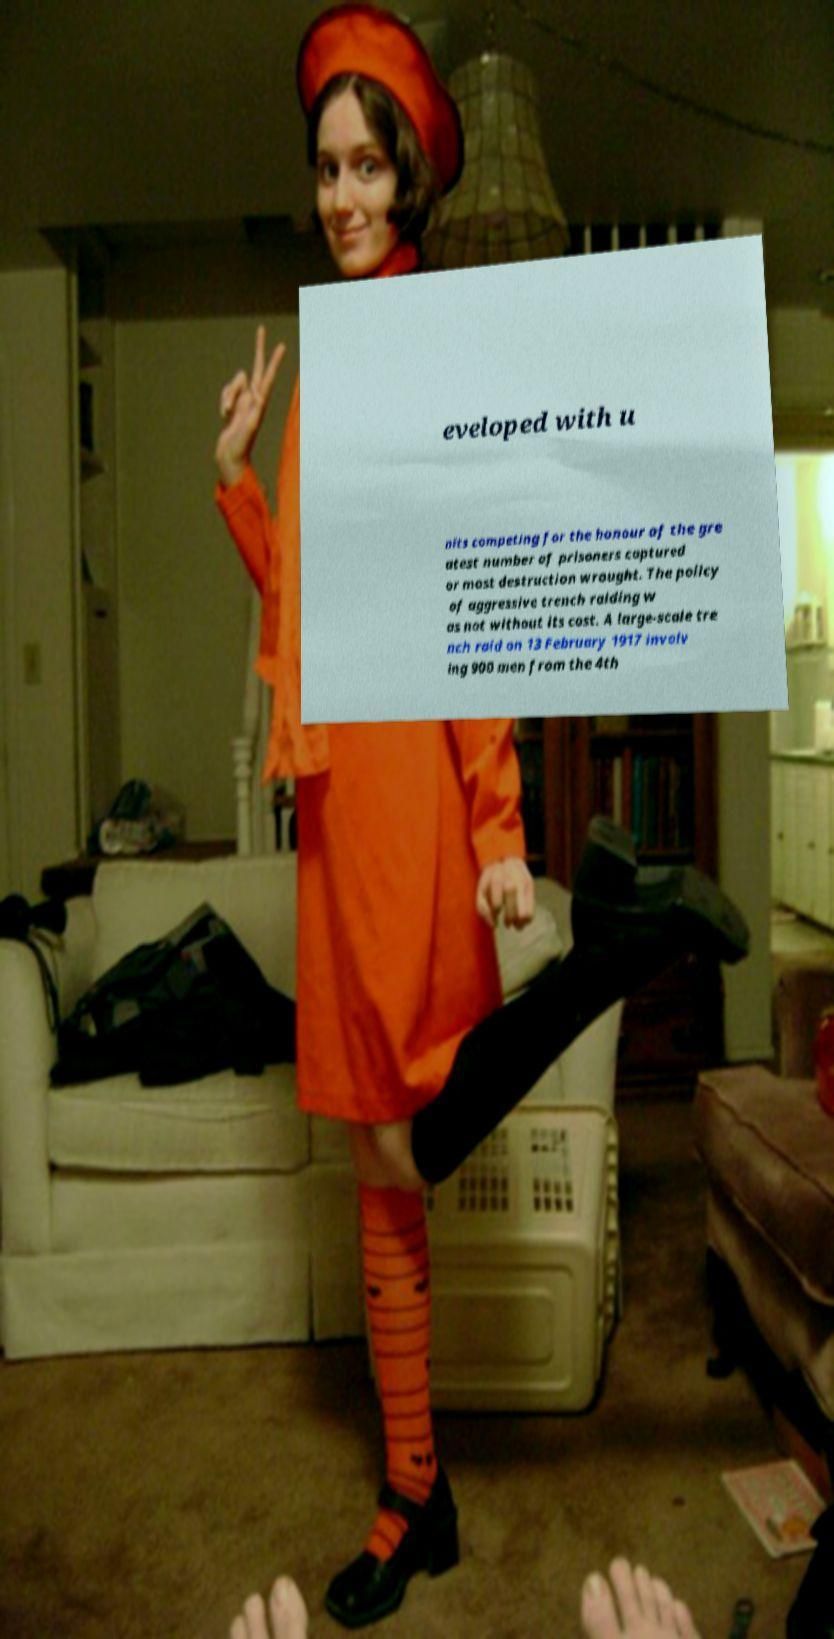Can you accurately transcribe the text from the provided image for me? eveloped with u nits competing for the honour of the gre atest number of prisoners captured or most destruction wrought. The policy of aggressive trench raiding w as not without its cost. A large-scale tre nch raid on 13 February 1917 involv ing 900 men from the 4th 